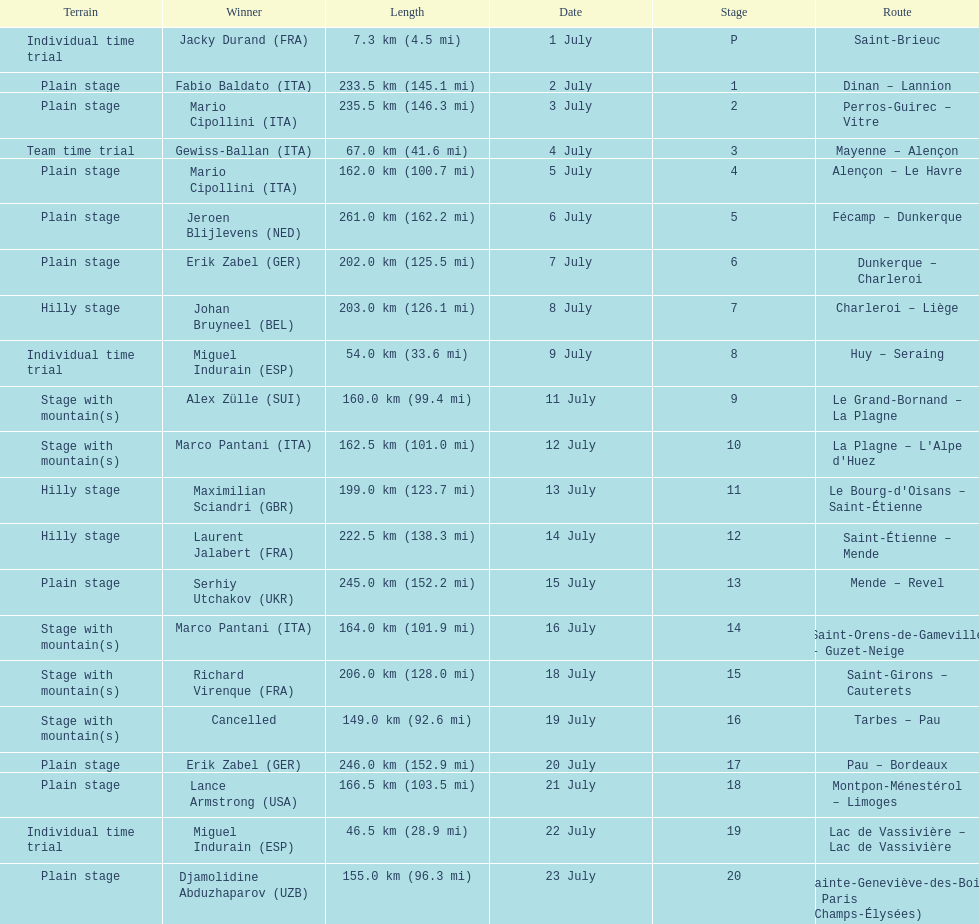Which country had more stage-winners than any other country? Italy. 